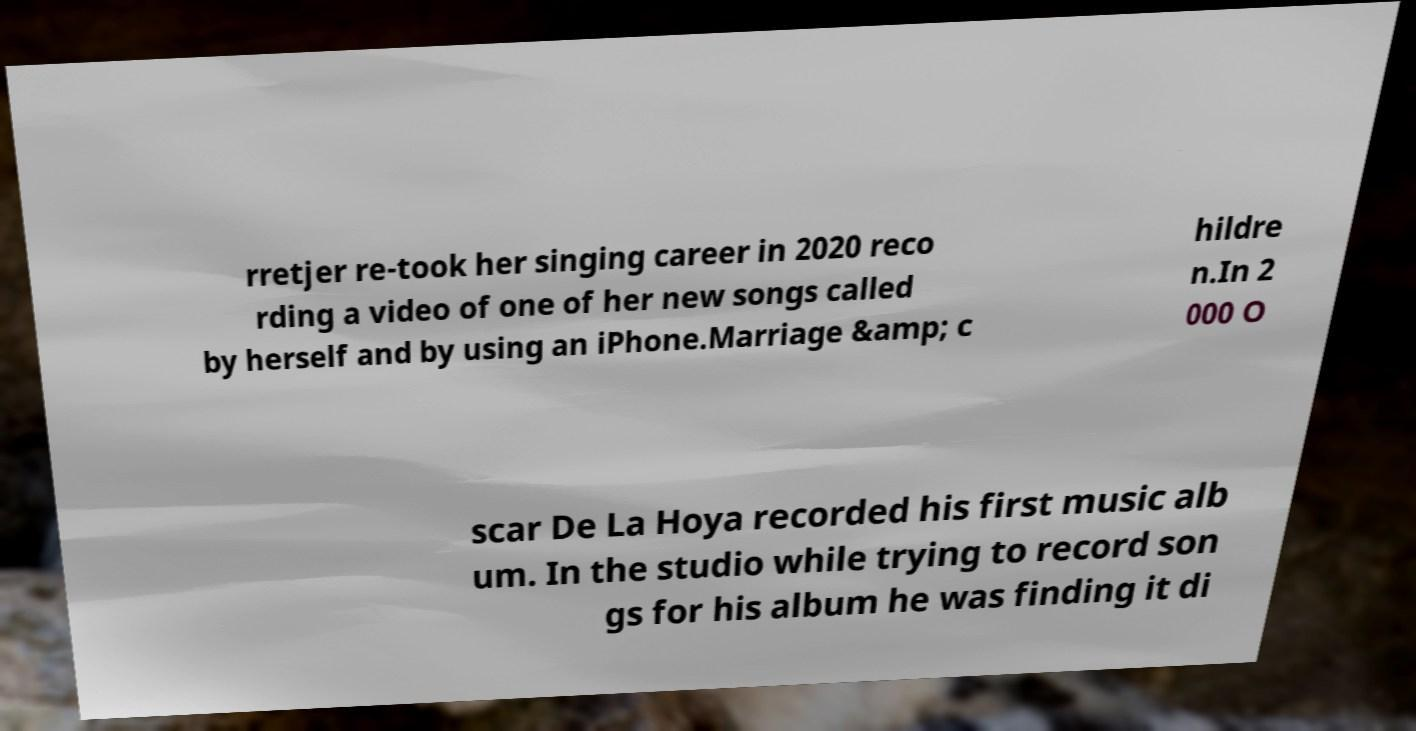There's text embedded in this image that I need extracted. Can you transcribe it verbatim? rretjer re-took her singing career in 2020 reco rding a video of one of her new songs called by herself and by using an iPhone.Marriage &amp; c hildre n.In 2 000 O scar De La Hoya recorded his first music alb um. In the studio while trying to record son gs for his album he was finding it di 